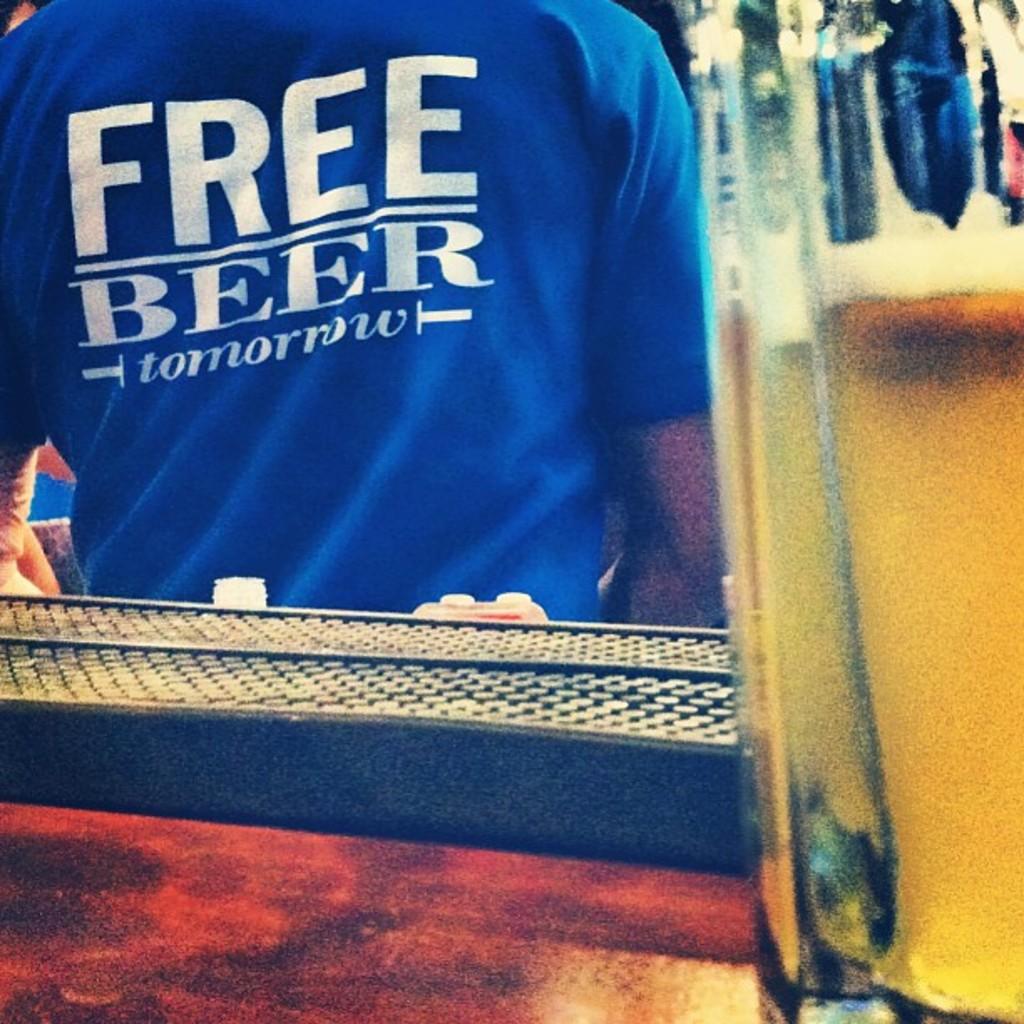What beverage will be free?
Keep it short and to the point. Beer. 